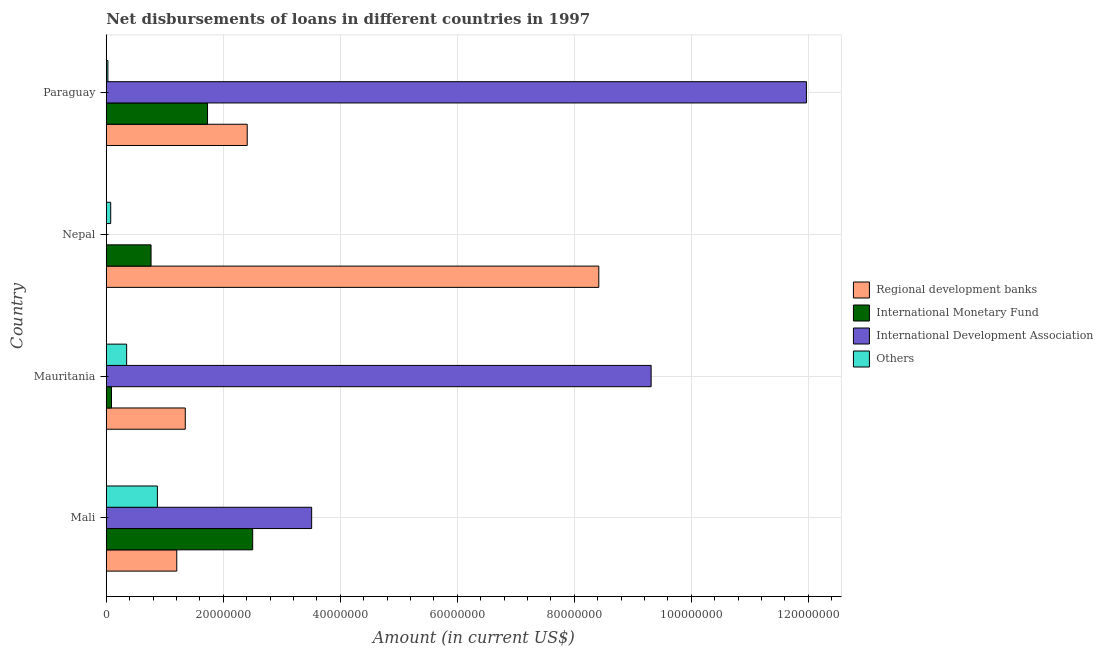How many different coloured bars are there?
Provide a succinct answer. 4. How many groups of bars are there?
Your response must be concise. 4. Are the number of bars per tick equal to the number of legend labels?
Your answer should be compact. No. What is the label of the 1st group of bars from the top?
Offer a terse response. Paraguay. In how many cases, is the number of bars for a given country not equal to the number of legend labels?
Offer a terse response. 1. What is the amount of loan disimbursed by international monetary fund in Paraguay?
Offer a very short reply. 1.73e+07. Across all countries, what is the maximum amount of loan disimbursed by other organisations?
Your response must be concise. 8.74e+06. Across all countries, what is the minimum amount of loan disimbursed by regional development banks?
Ensure brevity in your answer.  1.21e+07. In which country was the amount of loan disimbursed by regional development banks maximum?
Offer a terse response. Nepal. What is the total amount of loan disimbursed by international development association in the graph?
Provide a succinct answer. 2.48e+08. What is the difference between the amount of loan disimbursed by regional development banks in Mauritania and that in Paraguay?
Make the answer very short. -1.06e+07. What is the difference between the amount of loan disimbursed by other organisations in Paraguay and the amount of loan disimbursed by international development association in Mauritania?
Make the answer very short. -9.28e+07. What is the average amount of loan disimbursed by international monetary fund per country?
Give a very brief answer. 1.27e+07. What is the difference between the amount of loan disimbursed by other organisations and amount of loan disimbursed by international monetary fund in Mali?
Your answer should be compact. -1.63e+07. In how many countries, is the amount of loan disimbursed by international monetary fund greater than 40000000 US$?
Give a very brief answer. 0. What is the ratio of the amount of loan disimbursed by other organisations in Nepal to that in Paraguay?
Your response must be concise. 2.68. Is the amount of loan disimbursed by international development association in Mali less than that in Paraguay?
Your answer should be compact. Yes. What is the difference between the highest and the second highest amount of loan disimbursed by international monetary fund?
Ensure brevity in your answer.  7.72e+06. What is the difference between the highest and the lowest amount of loan disimbursed by regional development banks?
Your answer should be very brief. 7.21e+07. In how many countries, is the amount of loan disimbursed by regional development banks greater than the average amount of loan disimbursed by regional development banks taken over all countries?
Make the answer very short. 1. How many bars are there?
Provide a short and direct response. 15. Are all the bars in the graph horizontal?
Offer a terse response. Yes. How many countries are there in the graph?
Give a very brief answer. 4. Are the values on the major ticks of X-axis written in scientific E-notation?
Offer a terse response. No. Does the graph contain any zero values?
Offer a terse response. Yes. Does the graph contain grids?
Your response must be concise. Yes. How are the legend labels stacked?
Ensure brevity in your answer.  Vertical. What is the title of the graph?
Provide a short and direct response. Net disbursements of loans in different countries in 1997. Does "Payroll services" appear as one of the legend labels in the graph?
Provide a succinct answer. No. What is the label or title of the Y-axis?
Your response must be concise. Country. What is the Amount (in current US$) of Regional development banks in Mali?
Your answer should be very brief. 1.21e+07. What is the Amount (in current US$) in International Monetary Fund in Mali?
Your answer should be compact. 2.50e+07. What is the Amount (in current US$) in International Development Association in Mali?
Give a very brief answer. 3.51e+07. What is the Amount (in current US$) of Others in Mali?
Provide a succinct answer. 8.74e+06. What is the Amount (in current US$) of Regional development banks in Mauritania?
Offer a terse response. 1.35e+07. What is the Amount (in current US$) of International Monetary Fund in Mauritania?
Provide a short and direct response. 8.96e+05. What is the Amount (in current US$) of International Development Association in Mauritania?
Keep it short and to the point. 9.31e+07. What is the Amount (in current US$) of Others in Mauritania?
Ensure brevity in your answer.  3.49e+06. What is the Amount (in current US$) of Regional development banks in Nepal?
Offer a very short reply. 8.42e+07. What is the Amount (in current US$) in International Monetary Fund in Nepal?
Offer a very short reply. 7.66e+06. What is the Amount (in current US$) in International Development Association in Nepal?
Ensure brevity in your answer.  0. What is the Amount (in current US$) in Others in Nepal?
Provide a succinct answer. 7.61e+05. What is the Amount (in current US$) in Regional development banks in Paraguay?
Offer a very short reply. 2.41e+07. What is the Amount (in current US$) in International Monetary Fund in Paraguay?
Offer a very short reply. 1.73e+07. What is the Amount (in current US$) of International Development Association in Paraguay?
Give a very brief answer. 1.20e+08. What is the Amount (in current US$) in Others in Paraguay?
Ensure brevity in your answer.  2.84e+05. Across all countries, what is the maximum Amount (in current US$) of Regional development banks?
Offer a very short reply. 8.42e+07. Across all countries, what is the maximum Amount (in current US$) of International Monetary Fund?
Your answer should be very brief. 2.50e+07. Across all countries, what is the maximum Amount (in current US$) of International Development Association?
Offer a very short reply. 1.20e+08. Across all countries, what is the maximum Amount (in current US$) in Others?
Offer a terse response. 8.74e+06. Across all countries, what is the minimum Amount (in current US$) in Regional development banks?
Provide a short and direct response. 1.21e+07. Across all countries, what is the minimum Amount (in current US$) in International Monetary Fund?
Offer a very short reply. 8.96e+05. Across all countries, what is the minimum Amount (in current US$) of Others?
Provide a short and direct response. 2.84e+05. What is the total Amount (in current US$) in Regional development banks in the graph?
Ensure brevity in your answer.  1.34e+08. What is the total Amount (in current US$) in International Monetary Fund in the graph?
Keep it short and to the point. 5.09e+07. What is the total Amount (in current US$) of International Development Association in the graph?
Your response must be concise. 2.48e+08. What is the total Amount (in current US$) of Others in the graph?
Your response must be concise. 1.33e+07. What is the difference between the Amount (in current US$) in Regional development banks in Mali and that in Mauritania?
Your answer should be compact. -1.46e+06. What is the difference between the Amount (in current US$) in International Monetary Fund in Mali and that in Mauritania?
Keep it short and to the point. 2.41e+07. What is the difference between the Amount (in current US$) of International Development Association in Mali and that in Mauritania?
Keep it short and to the point. -5.80e+07. What is the difference between the Amount (in current US$) of Others in Mali and that in Mauritania?
Your answer should be compact. 5.25e+06. What is the difference between the Amount (in current US$) in Regional development banks in Mali and that in Nepal?
Provide a succinct answer. -7.21e+07. What is the difference between the Amount (in current US$) of International Monetary Fund in Mali and that in Nepal?
Ensure brevity in your answer.  1.74e+07. What is the difference between the Amount (in current US$) in Others in Mali and that in Nepal?
Your answer should be very brief. 7.98e+06. What is the difference between the Amount (in current US$) in Regional development banks in Mali and that in Paraguay?
Your answer should be compact. -1.20e+07. What is the difference between the Amount (in current US$) of International Monetary Fund in Mali and that in Paraguay?
Offer a terse response. 7.72e+06. What is the difference between the Amount (in current US$) in International Development Association in Mali and that in Paraguay?
Ensure brevity in your answer.  -8.46e+07. What is the difference between the Amount (in current US$) in Others in Mali and that in Paraguay?
Your response must be concise. 8.45e+06. What is the difference between the Amount (in current US$) in Regional development banks in Mauritania and that in Nepal?
Ensure brevity in your answer.  -7.07e+07. What is the difference between the Amount (in current US$) in International Monetary Fund in Mauritania and that in Nepal?
Offer a very short reply. -6.76e+06. What is the difference between the Amount (in current US$) of Others in Mauritania and that in Nepal?
Your answer should be very brief. 2.72e+06. What is the difference between the Amount (in current US$) in Regional development banks in Mauritania and that in Paraguay?
Provide a short and direct response. -1.06e+07. What is the difference between the Amount (in current US$) in International Monetary Fund in Mauritania and that in Paraguay?
Ensure brevity in your answer.  -1.64e+07. What is the difference between the Amount (in current US$) in International Development Association in Mauritania and that in Paraguay?
Provide a short and direct response. -2.65e+07. What is the difference between the Amount (in current US$) in Others in Mauritania and that in Paraguay?
Your response must be concise. 3.20e+06. What is the difference between the Amount (in current US$) in Regional development banks in Nepal and that in Paraguay?
Offer a terse response. 6.01e+07. What is the difference between the Amount (in current US$) in International Monetary Fund in Nepal and that in Paraguay?
Give a very brief answer. -9.65e+06. What is the difference between the Amount (in current US$) in Others in Nepal and that in Paraguay?
Ensure brevity in your answer.  4.77e+05. What is the difference between the Amount (in current US$) of Regional development banks in Mali and the Amount (in current US$) of International Monetary Fund in Mauritania?
Provide a short and direct response. 1.12e+07. What is the difference between the Amount (in current US$) in Regional development banks in Mali and the Amount (in current US$) in International Development Association in Mauritania?
Your response must be concise. -8.11e+07. What is the difference between the Amount (in current US$) in Regional development banks in Mali and the Amount (in current US$) in Others in Mauritania?
Offer a terse response. 8.57e+06. What is the difference between the Amount (in current US$) of International Monetary Fund in Mali and the Amount (in current US$) of International Development Association in Mauritania?
Ensure brevity in your answer.  -6.81e+07. What is the difference between the Amount (in current US$) in International Monetary Fund in Mali and the Amount (in current US$) in Others in Mauritania?
Offer a very short reply. 2.15e+07. What is the difference between the Amount (in current US$) in International Development Association in Mali and the Amount (in current US$) in Others in Mauritania?
Provide a succinct answer. 3.16e+07. What is the difference between the Amount (in current US$) in Regional development banks in Mali and the Amount (in current US$) in International Monetary Fund in Nepal?
Provide a succinct answer. 4.39e+06. What is the difference between the Amount (in current US$) in Regional development banks in Mali and the Amount (in current US$) in Others in Nepal?
Your answer should be compact. 1.13e+07. What is the difference between the Amount (in current US$) of International Monetary Fund in Mali and the Amount (in current US$) of Others in Nepal?
Give a very brief answer. 2.43e+07. What is the difference between the Amount (in current US$) of International Development Association in Mali and the Amount (in current US$) of Others in Nepal?
Your answer should be very brief. 3.43e+07. What is the difference between the Amount (in current US$) in Regional development banks in Mali and the Amount (in current US$) in International Monetary Fund in Paraguay?
Provide a short and direct response. -5.26e+06. What is the difference between the Amount (in current US$) in Regional development banks in Mali and the Amount (in current US$) in International Development Association in Paraguay?
Your answer should be compact. -1.08e+08. What is the difference between the Amount (in current US$) in Regional development banks in Mali and the Amount (in current US$) in Others in Paraguay?
Offer a very short reply. 1.18e+07. What is the difference between the Amount (in current US$) of International Monetary Fund in Mali and the Amount (in current US$) of International Development Association in Paraguay?
Your answer should be very brief. -9.46e+07. What is the difference between the Amount (in current US$) of International Monetary Fund in Mali and the Amount (in current US$) of Others in Paraguay?
Provide a short and direct response. 2.47e+07. What is the difference between the Amount (in current US$) in International Development Association in Mali and the Amount (in current US$) in Others in Paraguay?
Provide a short and direct response. 3.48e+07. What is the difference between the Amount (in current US$) of Regional development banks in Mauritania and the Amount (in current US$) of International Monetary Fund in Nepal?
Your response must be concise. 5.85e+06. What is the difference between the Amount (in current US$) in Regional development banks in Mauritania and the Amount (in current US$) in Others in Nepal?
Give a very brief answer. 1.27e+07. What is the difference between the Amount (in current US$) of International Monetary Fund in Mauritania and the Amount (in current US$) of Others in Nepal?
Provide a short and direct response. 1.35e+05. What is the difference between the Amount (in current US$) of International Development Association in Mauritania and the Amount (in current US$) of Others in Nepal?
Make the answer very short. 9.24e+07. What is the difference between the Amount (in current US$) of Regional development banks in Mauritania and the Amount (in current US$) of International Monetary Fund in Paraguay?
Ensure brevity in your answer.  -3.80e+06. What is the difference between the Amount (in current US$) in Regional development banks in Mauritania and the Amount (in current US$) in International Development Association in Paraguay?
Give a very brief answer. -1.06e+08. What is the difference between the Amount (in current US$) of Regional development banks in Mauritania and the Amount (in current US$) of Others in Paraguay?
Offer a very short reply. 1.32e+07. What is the difference between the Amount (in current US$) in International Monetary Fund in Mauritania and the Amount (in current US$) in International Development Association in Paraguay?
Your response must be concise. -1.19e+08. What is the difference between the Amount (in current US$) in International Monetary Fund in Mauritania and the Amount (in current US$) in Others in Paraguay?
Your answer should be compact. 6.12e+05. What is the difference between the Amount (in current US$) of International Development Association in Mauritania and the Amount (in current US$) of Others in Paraguay?
Make the answer very short. 9.28e+07. What is the difference between the Amount (in current US$) of Regional development banks in Nepal and the Amount (in current US$) of International Monetary Fund in Paraguay?
Your answer should be compact. 6.69e+07. What is the difference between the Amount (in current US$) in Regional development banks in Nepal and the Amount (in current US$) in International Development Association in Paraguay?
Your response must be concise. -3.55e+07. What is the difference between the Amount (in current US$) of Regional development banks in Nepal and the Amount (in current US$) of Others in Paraguay?
Your response must be concise. 8.39e+07. What is the difference between the Amount (in current US$) of International Monetary Fund in Nepal and the Amount (in current US$) of International Development Association in Paraguay?
Keep it short and to the point. -1.12e+08. What is the difference between the Amount (in current US$) in International Monetary Fund in Nepal and the Amount (in current US$) in Others in Paraguay?
Offer a terse response. 7.37e+06. What is the average Amount (in current US$) of Regional development banks per country?
Offer a very short reply. 3.35e+07. What is the average Amount (in current US$) of International Monetary Fund per country?
Your response must be concise. 1.27e+07. What is the average Amount (in current US$) of International Development Association per country?
Your answer should be very brief. 6.20e+07. What is the average Amount (in current US$) in Others per country?
Offer a terse response. 3.32e+06. What is the difference between the Amount (in current US$) in Regional development banks and Amount (in current US$) in International Monetary Fund in Mali?
Your answer should be very brief. -1.30e+07. What is the difference between the Amount (in current US$) of Regional development banks and Amount (in current US$) of International Development Association in Mali?
Your answer should be very brief. -2.31e+07. What is the difference between the Amount (in current US$) of Regional development banks and Amount (in current US$) of Others in Mali?
Your answer should be compact. 3.31e+06. What is the difference between the Amount (in current US$) in International Monetary Fund and Amount (in current US$) in International Development Association in Mali?
Make the answer very short. -1.01e+07. What is the difference between the Amount (in current US$) in International Monetary Fund and Amount (in current US$) in Others in Mali?
Keep it short and to the point. 1.63e+07. What is the difference between the Amount (in current US$) of International Development Association and Amount (in current US$) of Others in Mali?
Your answer should be compact. 2.64e+07. What is the difference between the Amount (in current US$) in Regional development banks and Amount (in current US$) in International Monetary Fund in Mauritania?
Ensure brevity in your answer.  1.26e+07. What is the difference between the Amount (in current US$) in Regional development banks and Amount (in current US$) in International Development Association in Mauritania?
Offer a terse response. -7.96e+07. What is the difference between the Amount (in current US$) in Regional development banks and Amount (in current US$) in Others in Mauritania?
Give a very brief answer. 1.00e+07. What is the difference between the Amount (in current US$) of International Monetary Fund and Amount (in current US$) of International Development Association in Mauritania?
Offer a very short reply. -9.22e+07. What is the difference between the Amount (in current US$) in International Monetary Fund and Amount (in current US$) in Others in Mauritania?
Provide a short and direct response. -2.59e+06. What is the difference between the Amount (in current US$) of International Development Association and Amount (in current US$) of Others in Mauritania?
Provide a succinct answer. 8.96e+07. What is the difference between the Amount (in current US$) in Regional development banks and Amount (in current US$) in International Monetary Fund in Nepal?
Your answer should be very brief. 7.65e+07. What is the difference between the Amount (in current US$) of Regional development banks and Amount (in current US$) of Others in Nepal?
Give a very brief answer. 8.34e+07. What is the difference between the Amount (in current US$) in International Monetary Fund and Amount (in current US$) in Others in Nepal?
Ensure brevity in your answer.  6.90e+06. What is the difference between the Amount (in current US$) of Regional development banks and Amount (in current US$) of International Monetary Fund in Paraguay?
Your answer should be very brief. 6.78e+06. What is the difference between the Amount (in current US$) in Regional development banks and Amount (in current US$) in International Development Association in Paraguay?
Offer a terse response. -9.56e+07. What is the difference between the Amount (in current US$) in Regional development banks and Amount (in current US$) in Others in Paraguay?
Provide a short and direct response. 2.38e+07. What is the difference between the Amount (in current US$) of International Monetary Fund and Amount (in current US$) of International Development Association in Paraguay?
Provide a short and direct response. -1.02e+08. What is the difference between the Amount (in current US$) of International Monetary Fund and Amount (in current US$) of Others in Paraguay?
Your answer should be compact. 1.70e+07. What is the difference between the Amount (in current US$) in International Development Association and Amount (in current US$) in Others in Paraguay?
Offer a terse response. 1.19e+08. What is the ratio of the Amount (in current US$) of Regional development banks in Mali to that in Mauritania?
Offer a very short reply. 0.89. What is the ratio of the Amount (in current US$) of International Monetary Fund in Mali to that in Mauritania?
Provide a short and direct response. 27.93. What is the ratio of the Amount (in current US$) of International Development Association in Mali to that in Mauritania?
Give a very brief answer. 0.38. What is the ratio of the Amount (in current US$) of Others in Mali to that in Mauritania?
Make the answer very short. 2.51. What is the ratio of the Amount (in current US$) in Regional development banks in Mali to that in Nepal?
Your answer should be very brief. 0.14. What is the ratio of the Amount (in current US$) in International Monetary Fund in Mali to that in Nepal?
Provide a succinct answer. 3.27. What is the ratio of the Amount (in current US$) in Others in Mali to that in Nepal?
Ensure brevity in your answer.  11.48. What is the ratio of the Amount (in current US$) in Regional development banks in Mali to that in Paraguay?
Ensure brevity in your answer.  0.5. What is the ratio of the Amount (in current US$) of International Monetary Fund in Mali to that in Paraguay?
Offer a terse response. 1.45. What is the ratio of the Amount (in current US$) of International Development Association in Mali to that in Paraguay?
Your response must be concise. 0.29. What is the ratio of the Amount (in current US$) of Others in Mali to that in Paraguay?
Your response must be concise. 30.77. What is the ratio of the Amount (in current US$) in Regional development banks in Mauritania to that in Nepal?
Offer a very short reply. 0.16. What is the ratio of the Amount (in current US$) of International Monetary Fund in Mauritania to that in Nepal?
Provide a succinct answer. 0.12. What is the ratio of the Amount (in current US$) of Others in Mauritania to that in Nepal?
Provide a succinct answer. 4.58. What is the ratio of the Amount (in current US$) in Regional development banks in Mauritania to that in Paraguay?
Keep it short and to the point. 0.56. What is the ratio of the Amount (in current US$) of International Monetary Fund in Mauritania to that in Paraguay?
Offer a terse response. 0.05. What is the ratio of the Amount (in current US$) of International Development Association in Mauritania to that in Paraguay?
Ensure brevity in your answer.  0.78. What is the ratio of the Amount (in current US$) in Others in Mauritania to that in Paraguay?
Your response must be concise. 12.27. What is the ratio of the Amount (in current US$) of Regional development banks in Nepal to that in Paraguay?
Offer a terse response. 3.49. What is the ratio of the Amount (in current US$) in International Monetary Fund in Nepal to that in Paraguay?
Provide a short and direct response. 0.44. What is the ratio of the Amount (in current US$) in Others in Nepal to that in Paraguay?
Ensure brevity in your answer.  2.68. What is the difference between the highest and the second highest Amount (in current US$) of Regional development banks?
Provide a short and direct response. 6.01e+07. What is the difference between the highest and the second highest Amount (in current US$) of International Monetary Fund?
Your answer should be compact. 7.72e+06. What is the difference between the highest and the second highest Amount (in current US$) in International Development Association?
Give a very brief answer. 2.65e+07. What is the difference between the highest and the second highest Amount (in current US$) of Others?
Your answer should be compact. 5.25e+06. What is the difference between the highest and the lowest Amount (in current US$) in Regional development banks?
Provide a short and direct response. 7.21e+07. What is the difference between the highest and the lowest Amount (in current US$) in International Monetary Fund?
Offer a terse response. 2.41e+07. What is the difference between the highest and the lowest Amount (in current US$) of International Development Association?
Provide a short and direct response. 1.20e+08. What is the difference between the highest and the lowest Amount (in current US$) in Others?
Keep it short and to the point. 8.45e+06. 